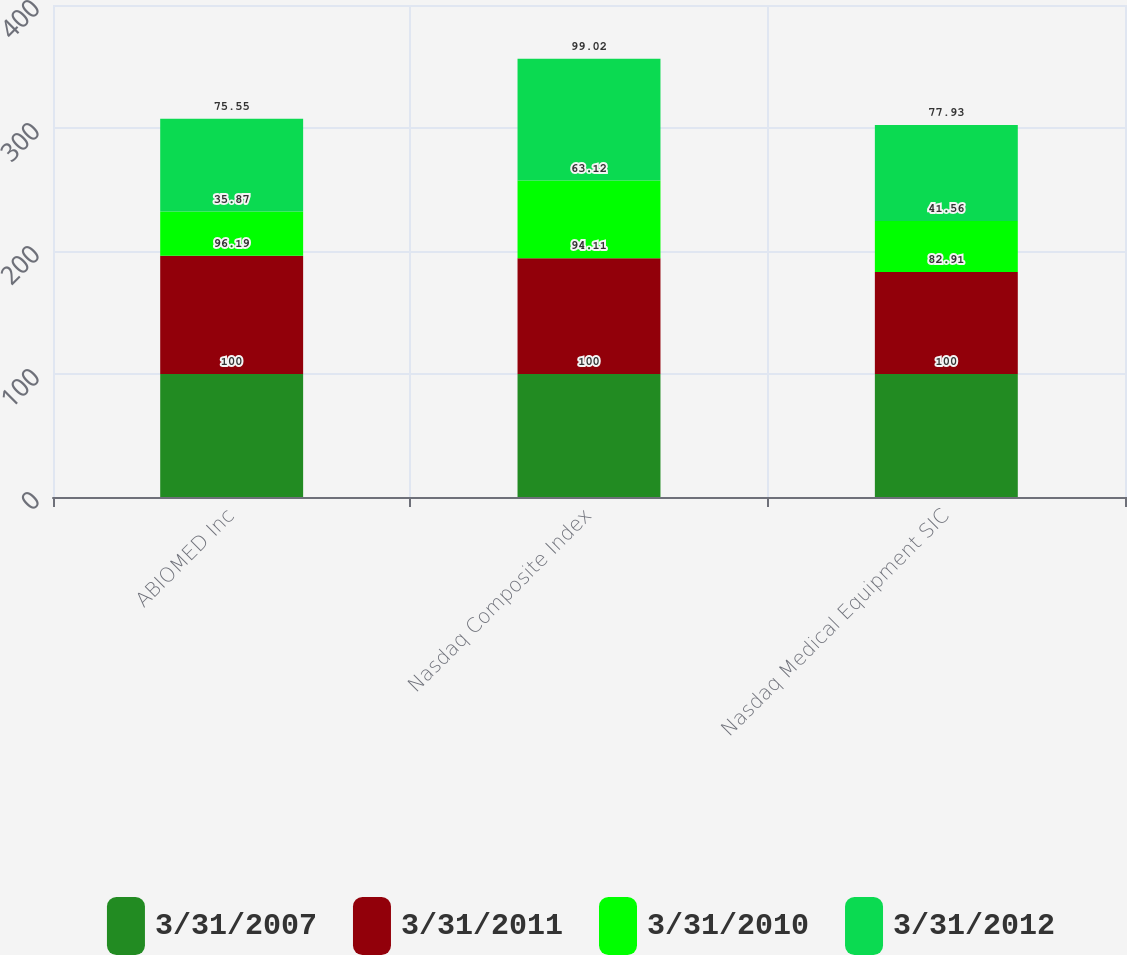Convert chart. <chart><loc_0><loc_0><loc_500><loc_500><stacked_bar_chart><ecel><fcel>ABIOMED Inc<fcel>Nasdaq Composite Index<fcel>Nasdaq Medical Equipment SIC<nl><fcel>3/31/2007<fcel>100<fcel>100<fcel>100<nl><fcel>3/31/2011<fcel>96.19<fcel>94.11<fcel>82.91<nl><fcel>3/31/2010<fcel>35.87<fcel>63.12<fcel>41.56<nl><fcel>3/31/2012<fcel>75.55<fcel>99.02<fcel>77.93<nl></chart> 